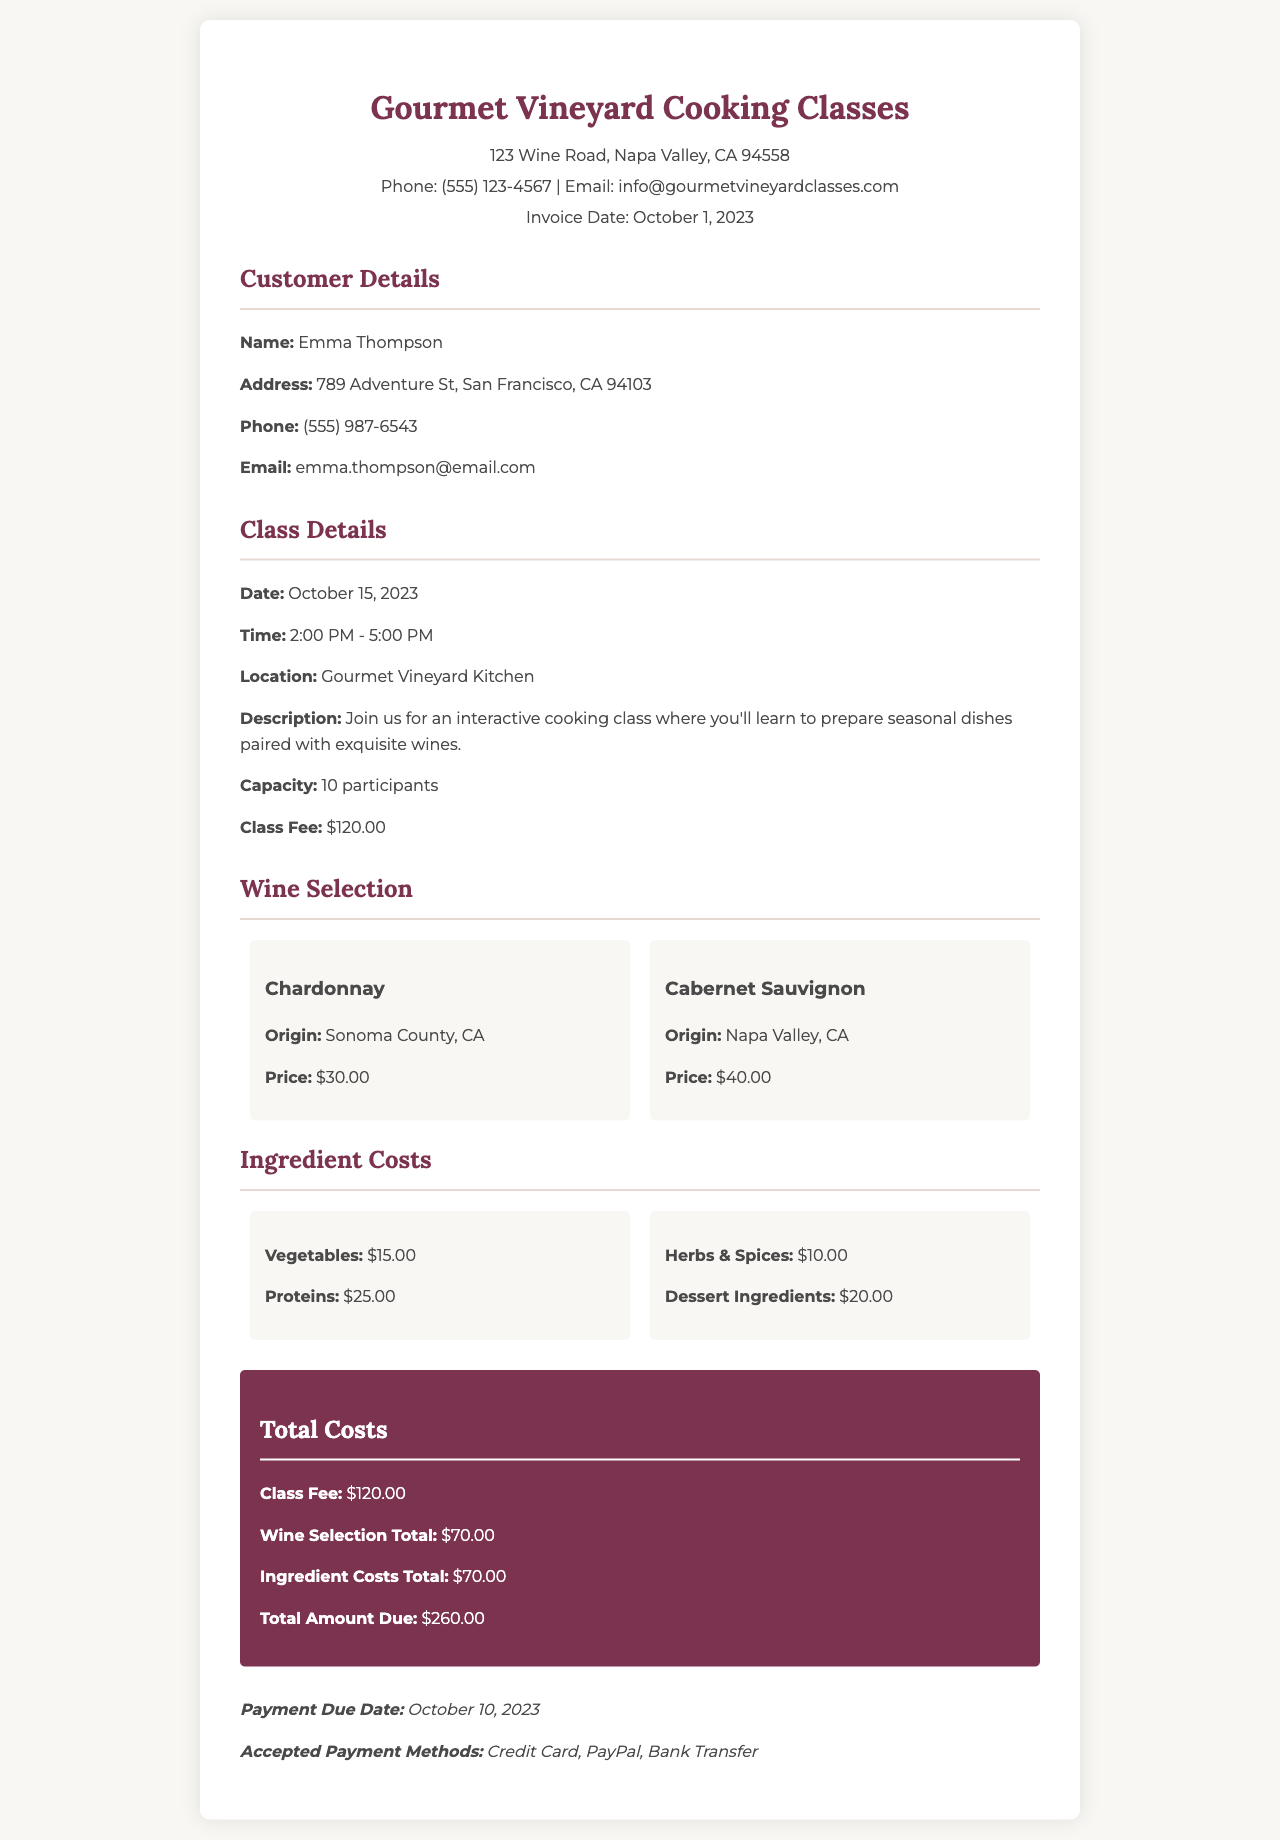What is the class fee? The class fee is clearly stated in the document under the class details section.
Answer: $120.00 What is the total amount due? The total amount due is summarized in the total costs section of the invoice.
Answer: $260.00 How many participants can join the class? The maximum capacity for the class is provided in the class details.
Answer: 10 participants What is the price of Cabernet Sauvignon? The price for Cabernet Sauvignon is listed in the wine selection section.
Answer: $40.00 What is the payment due date? The payment due date is specified in the payment terms section of the invoice.
Answer: October 10, 2023 Calculate the total costs for ingredients. The total costs for ingredients are derived from the individual costs listed for vegetables, proteins, herbs, spices, and dessert ingredients.
Answer: $70.00 What types of payment are accepted? The accepted payment methods are outlined in the payment terms section.
Answer: Credit Card, PayPal, Bank Transfer Where is the cooking class taking place? The location of the cooking class is mentioned in the class details section.
Answer: Gourmet Vineyard Kitchen What is the origin of Chardonnay? The origin of Chardonnay is specified in the wine selection section.
Answer: Sonoma County, CA 